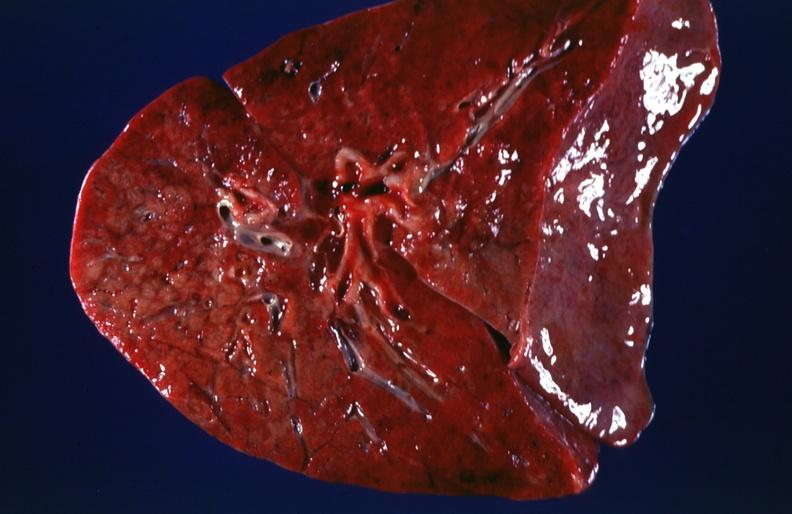what is present?
Answer the question using a single word or phrase. Respiratory 